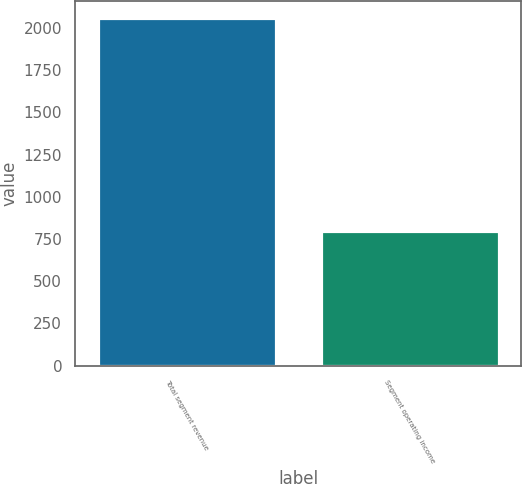<chart> <loc_0><loc_0><loc_500><loc_500><bar_chart><fcel>Total segment revenue<fcel>Segment operating income<nl><fcel>2057<fcel>800<nl></chart> 